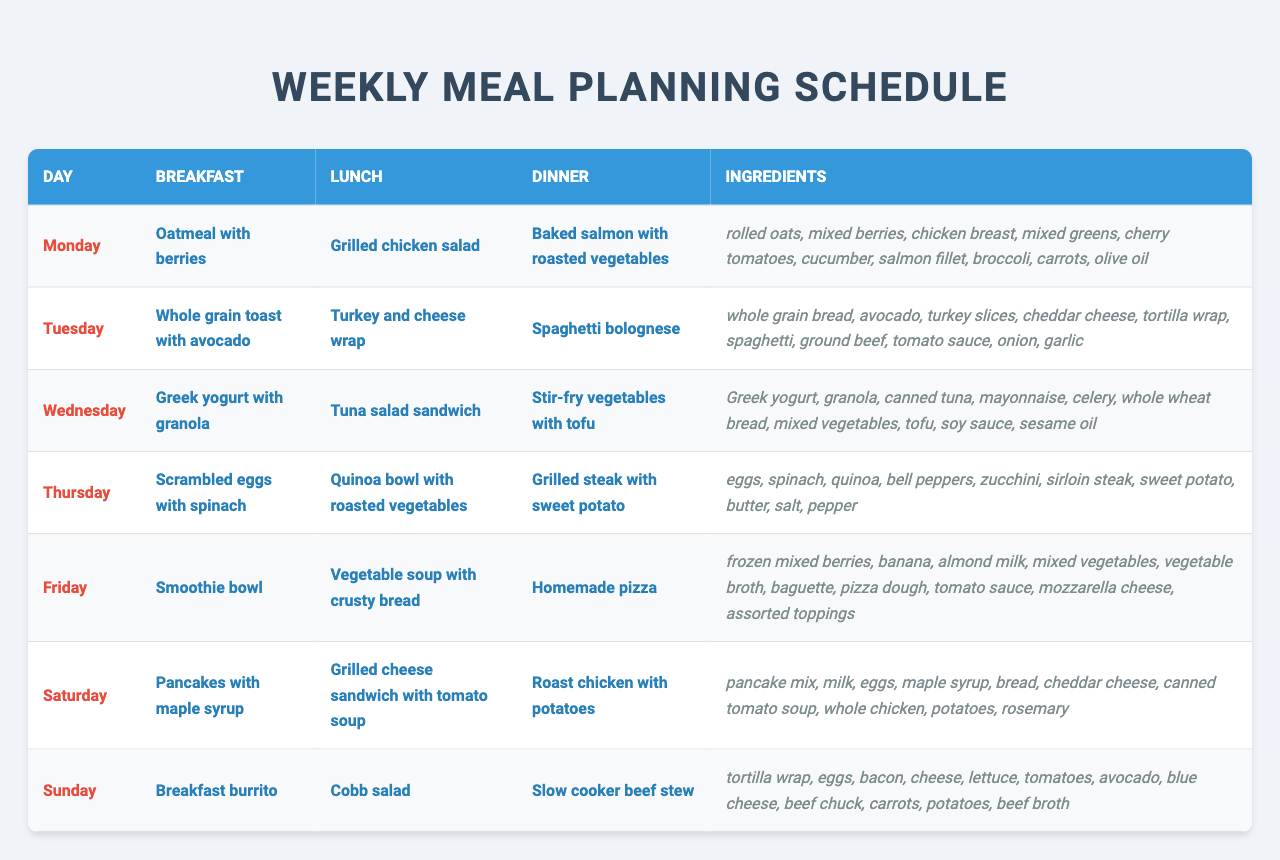What breakfast is served on Thursday? Thursday's breakfast is listed as scrambled eggs with spinach in the table.
Answer: Scrambled eggs with spinach Which dinner option includes chicken? The dinner options including chicken are 'Baked salmon with roasted vegetables' on Monday, 'Grilled steak with sweet potato' on Thursday, and 'Roast chicken with potatoes' on Saturday.
Answer: Roast chicken with potatoes How many different ingredients are used for the meals on Friday? The ingredients listed for Friday are frozen mixed berries, banana, almond milk, mixed vegetables, vegetable broth, baguette, pizza dough, tomato sauce, mozzarella cheese, and assorted toppings, which totals 10 different ingredients.
Answer: 10 Is there any day that features a smoothie for breakfast? The table shows that Friday has a 'Smoothie bowl' for breakfast, indicating that there is indeed a smoothie for breakfast on this day.
Answer: Yes What is the difference between the number of ingredients on Monday and Wednesday? Monday has 10 ingredients, while Wednesday has 10 ingredients as well; therefore, the difference is 0.
Answer: 0 Which lunch option has the most unique ingredients compared to the other days? The lunch options are 'Grilled chicken salad' (Monday), 'Turkey and cheese wrap' (Tuesday), 'Tuna salad sandwich' (Wednesday), 'Quinoa bowl with roasted vegetables' (Thursday), 'Vegetable soup with crusty bread' (Friday), 'Grilled cheese sandwich with tomato soup' (Saturday), and 'Cobb salad' (Sunday). Among these, the tuna salad sandwich includes canned tuna, mayonnaise, and celery as unique ingredients not found in other lunches.
Answer: Tuna salad sandwich What is the total count of vegetarian ingredients used in the meal plan? The vegetarian ingredients listed include rolled oats, mixed berries, mixed greens, cherry tomatoes, cucumber, broccoli, carrots, avocado, spinach, quinoa, bell peppers, zucchini, mixed vegetables, tofu, Greek yogurt, granola, and all soup-related ingredients, providing a total of 15 vegetarian ingredients.
Answer: 15 Which day has the least number of ingredients? After reviewing the meal plans, both Monday and Wednesday have 10 ingredients each, which is the least number recorded for any day.
Answer: 10 What meal is served on Sunday for lunch? The table indicates that the meal served for lunch on Sunday is a Cobb salad.
Answer: Cobb salad Identify any overlap in ingredients between Tuesday’s lunch and Thursday's dinner. Tuesday's lunch includes turkey slices and cheddar cheese, while Thursday's dinner does not share any of these ingredients; thus, there's no overlap in ingredients between these meals.
Answer: No overlap 